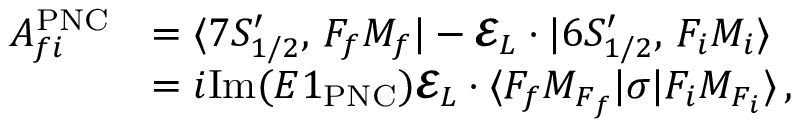Convert formula to latex. <formula><loc_0><loc_0><loc_500><loc_500>\begin{array} { r l } { A _ { f i } ^ { P N C } } & { = { \langle 7 S _ { 1 / 2 } ^ { \prime } , \, F _ { f } M _ { f } | } - \mathbf c a l { E } _ { L } \cdot { \ v { D } } { | 6 S _ { 1 / 2 } ^ { \prime } , \, F _ { i } M _ { i } \rangle } } \\ & { = i I m ( E 1 _ { P N C } ) \mathbf c a l { E } _ { L } \cdot { \langle F _ { f } M _ { F _ { f } } | } { \sigma } { | F _ { i } M _ { F _ { i } } \rangle } \, , } \end{array}</formula> 